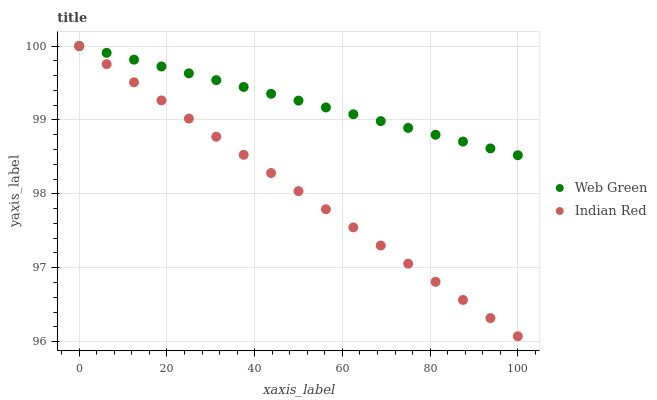Does Indian Red have the minimum area under the curve?
Answer yes or no. Yes. Does Web Green have the maximum area under the curve?
Answer yes or no. Yes. Does Web Green have the minimum area under the curve?
Answer yes or no. No. Is Web Green the smoothest?
Answer yes or no. Yes. Is Indian Red the roughest?
Answer yes or no. Yes. Is Web Green the roughest?
Answer yes or no. No. Does Indian Red have the lowest value?
Answer yes or no. Yes. Does Web Green have the lowest value?
Answer yes or no. No. Does Web Green have the highest value?
Answer yes or no. Yes. Does Indian Red intersect Web Green?
Answer yes or no. Yes. Is Indian Red less than Web Green?
Answer yes or no. No. Is Indian Red greater than Web Green?
Answer yes or no. No. 